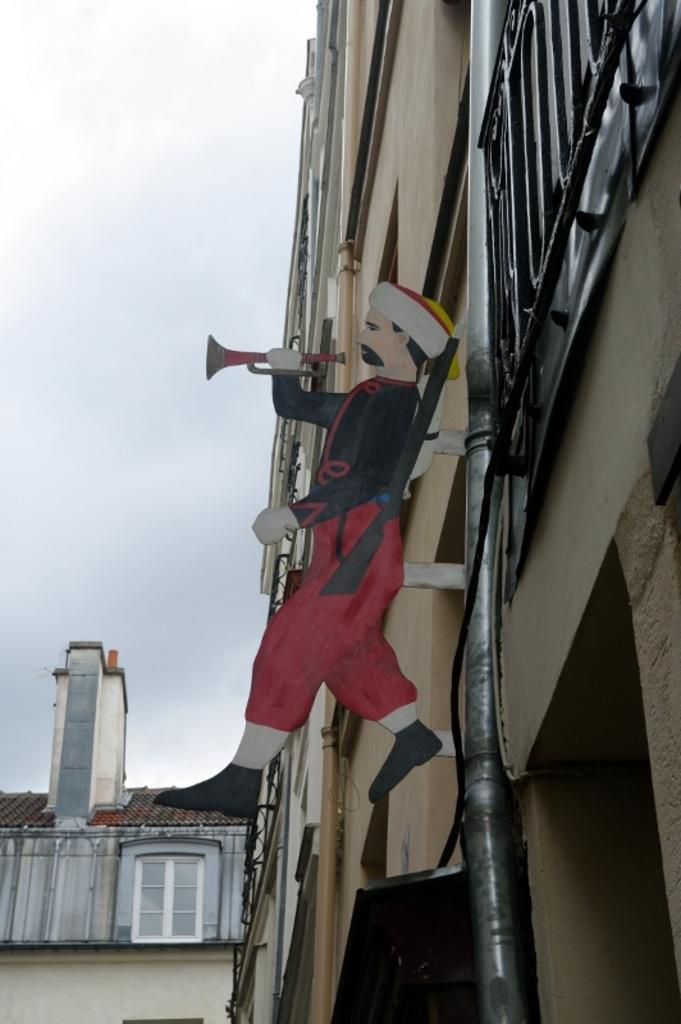What type of structure is present in the image? There is a building in the image. What is depicted on the building? There is a cartoon image on the building. What part of the sky can be seen in the image? The sky is visible on the left side of the image. What type of whistle can be heard coming from the building in the image? There is no whistle present in the image, and therefore no sound can be heard. 